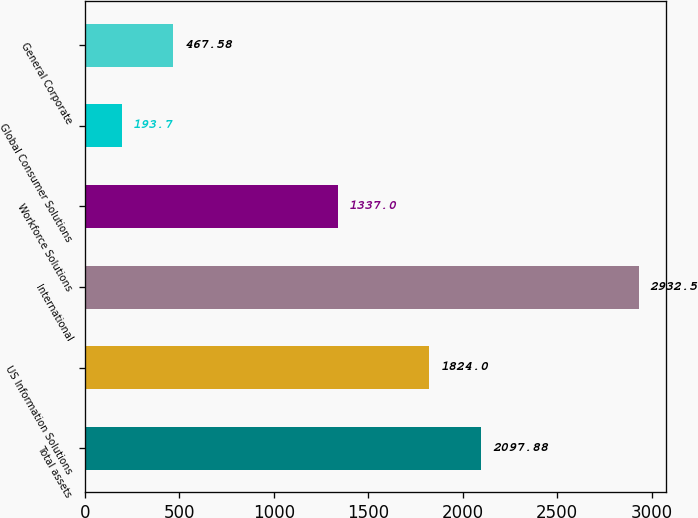Convert chart to OTSL. <chart><loc_0><loc_0><loc_500><loc_500><bar_chart><fcel>Total assets<fcel>US Information Solutions<fcel>International<fcel>Workforce Solutions<fcel>Global Consumer Solutions<fcel>General Corporate<nl><fcel>2097.88<fcel>1824<fcel>2932.5<fcel>1337<fcel>193.7<fcel>467.58<nl></chart> 